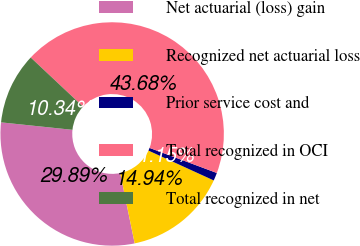Convert chart. <chart><loc_0><loc_0><loc_500><loc_500><pie_chart><fcel>Net actuarial (loss) gain<fcel>Recognized net actuarial loss<fcel>Prior service cost and<fcel>Total recognized in OCI<fcel>Total recognized in net<nl><fcel>29.89%<fcel>14.94%<fcel>1.15%<fcel>43.68%<fcel>10.34%<nl></chart> 